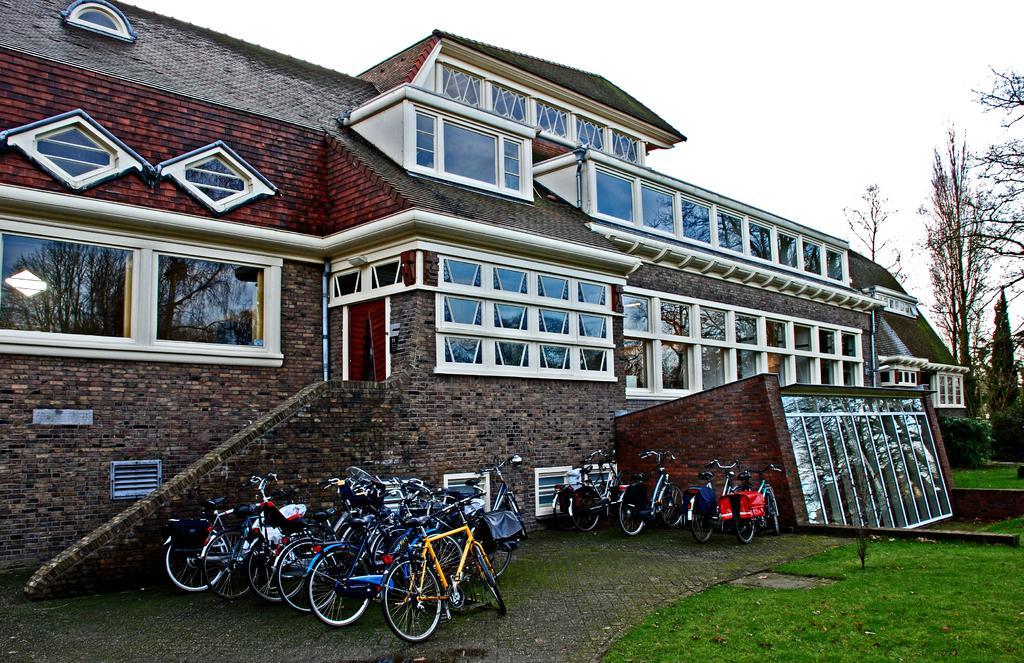In one or two sentences, can you explain what this image depicts? In the foreground of the image we can see a group of cycles with some bags placed on the ground. In the center of the image we can see a building with windows, glass door and the roof. On the right side of the image we can see grass, plants and some trees. At the top of the image we can see the sky. 